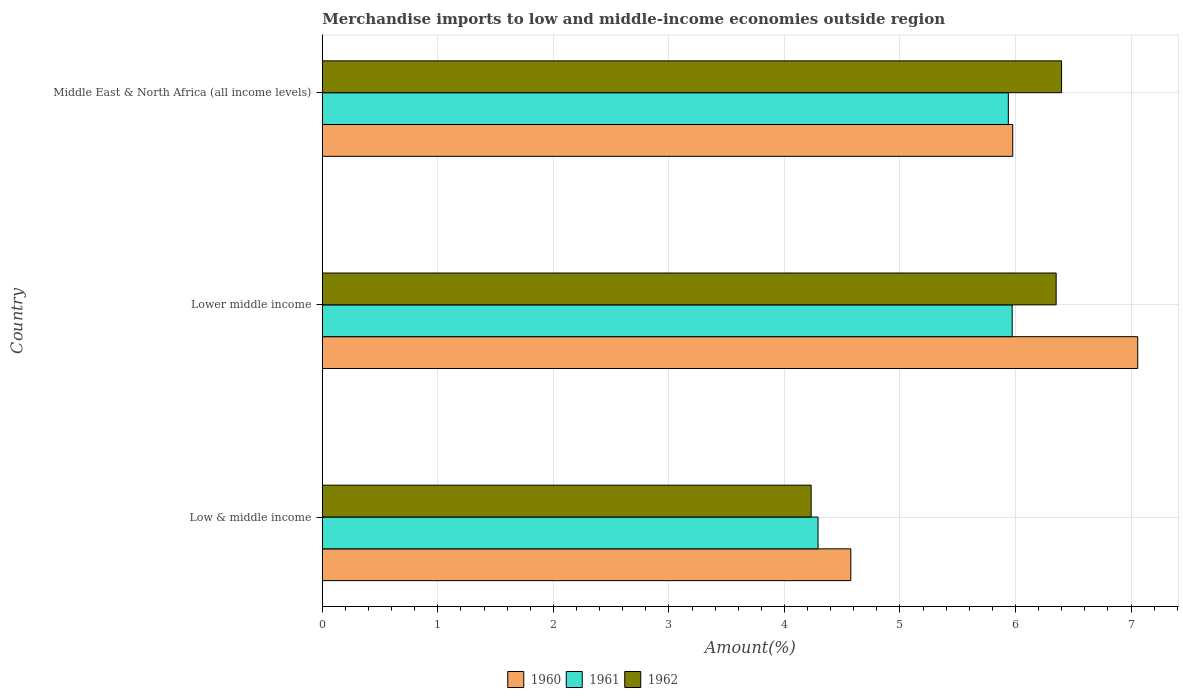How many different coloured bars are there?
Your response must be concise. 3. Are the number of bars per tick equal to the number of legend labels?
Your response must be concise. Yes. How many bars are there on the 3rd tick from the top?
Your response must be concise. 3. How many bars are there on the 1st tick from the bottom?
Provide a short and direct response. 3. What is the label of the 2nd group of bars from the top?
Provide a succinct answer. Lower middle income. What is the percentage of amount earned from merchandise imports in 1961 in Middle East & North Africa (all income levels)?
Provide a succinct answer. 5.94. Across all countries, what is the maximum percentage of amount earned from merchandise imports in 1960?
Give a very brief answer. 7.06. Across all countries, what is the minimum percentage of amount earned from merchandise imports in 1960?
Provide a short and direct response. 4.57. In which country was the percentage of amount earned from merchandise imports in 1961 maximum?
Keep it short and to the point. Lower middle income. In which country was the percentage of amount earned from merchandise imports in 1961 minimum?
Give a very brief answer. Low & middle income. What is the total percentage of amount earned from merchandise imports in 1960 in the graph?
Make the answer very short. 17.61. What is the difference between the percentage of amount earned from merchandise imports in 1960 in Low & middle income and that in Lower middle income?
Your answer should be compact. -2.48. What is the difference between the percentage of amount earned from merchandise imports in 1960 in Lower middle income and the percentage of amount earned from merchandise imports in 1962 in Middle East & North Africa (all income levels)?
Give a very brief answer. 0.66. What is the average percentage of amount earned from merchandise imports in 1960 per country?
Offer a terse response. 5.87. What is the difference between the percentage of amount earned from merchandise imports in 1961 and percentage of amount earned from merchandise imports in 1962 in Middle East & North Africa (all income levels)?
Keep it short and to the point. -0.46. In how many countries, is the percentage of amount earned from merchandise imports in 1962 greater than 4 %?
Offer a terse response. 3. What is the ratio of the percentage of amount earned from merchandise imports in 1960 in Lower middle income to that in Middle East & North Africa (all income levels)?
Offer a very short reply. 1.18. Is the difference between the percentage of amount earned from merchandise imports in 1961 in Low & middle income and Middle East & North Africa (all income levels) greater than the difference between the percentage of amount earned from merchandise imports in 1962 in Low & middle income and Middle East & North Africa (all income levels)?
Provide a succinct answer. Yes. What is the difference between the highest and the second highest percentage of amount earned from merchandise imports in 1962?
Ensure brevity in your answer.  0.05. What is the difference between the highest and the lowest percentage of amount earned from merchandise imports in 1962?
Give a very brief answer. 2.17. In how many countries, is the percentage of amount earned from merchandise imports in 1961 greater than the average percentage of amount earned from merchandise imports in 1961 taken over all countries?
Offer a very short reply. 2. What does the 2nd bar from the top in Middle East & North Africa (all income levels) represents?
Keep it short and to the point. 1961. What does the 2nd bar from the bottom in Middle East & North Africa (all income levels) represents?
Provide a short and direct response. 1961. Are all the bars in the graph horizontal?
Your response must be concise. Yes. How many countries are there in the graph?
Offer a terse response. 3. What is the difference between two consecutive major ticks on the X-axis?
Your answer should be compact. 1. Are the values on the major ticks of X-axis written in scientific E-notation?
Your response must be concise. No. Does the graph contain any zero values?
Your answer should be very brief. No. Does the graph contain grids?
Offer a very short reply. Yes. How many legend labels are there?
Keep it short and to the point. 3. How are the legend labels stacked?
Keep it short and to the point. Horizontal. What is the title of the graph?
Provide a short and direct response. Merchandise imports to low and middle-income economies outside region. What is the label or title of the X-axis?
Your response must be concise. Amount(%). What is the Amount(%) in 1960 in Low & middle income?
Give a very brief answer. 4.57. What is the Amount(%) in 1961 in Low & middle income?
Offer a very short reply. 4.29. What is the Amount(%) in 1962 in Low & middle income?
Provide a succinct answer. 4.23. What is the Amount(%) of 1960 in Lower middle income?
Offer a very short reply. 7.06. What is the Amount(%) of 1961 in Lower middle income?
Give a very brief answer. 5.97. What is the Amount(%) in 1962 in Lower middle income?
Your response must be concise. 6.35. What is the Amount(%) of 1960 in Middle East & North Africa (all income levels)?
Your answer should be compact. 5.98. What is the Amount(%) in 1961 in Middle East & North Africa (all income levels)?
Provide a succinct answer. 5.94. What is the Amount(%) in 1962 in Middle East & North Africa (all income levels)?
Give a very brief answer. 6.4. Across all countries, what is the maximum Amount(%) in 1960?
Ensure brevity in your answer.  7.06. Across all countries, what is the maximum Amount(%) of 1961?
Ensure brevity in your answer.  5.97. Across all countries, what is the maximum Amount(%) of 1962?
Your answer should be very brief. 6.4. Across all countries, what is the minimum Amount(%) of 1960?
Offer a terse response. 4.57. Across all countries, what is the minimum Amount(%) of 1961?
Provide a short and direct response. 4.29. Across all countries, what is the minimum Amount(%) of 1962?
Give a very brief answer. 4.23. What is the total Amount(%) in 1960 in the graph?
Your answer should be very brief. 17.61. What is the total Amount(%) in 1961 in the graph?
Your answer should be compact. 16.2. What is the total Amount(%) in 1962 in the graph?
Keep it short and to the point. 16.98. What is the difference between the Amount(%) of 1960 in Low & middle income and that in Lower middle income?
Keep it short and to the point. -2.48. What is the difference between the Amount(%) in 1961 in Low & middle income and that in Lower middle income?
Keep it short and to the point. -1.68. What is the difference between the Amount(%) of 1962 in Low & middle income and that in Lower middle income?
Provide a short and direct response. -2.12. What is the difference between the Amount(%) of 1960 in Low & middle income and that in Middle East & North Africa (all income levels)?
Provide a short and direct response. -1.4. What is the difference between the Amount(%) in 1961 in Low & middle income and that in Middle East & North Africa (all income levels)?
Your answer should be very brief. -1.65. What is the difference between the Amount(%) in 1962 in Low & middle income and that in Middle East & North Africa (all income levels)?
Give a very brief answer. -2.17. What is the difference between the Amount(%) of 1960 in Lower middle income and that in Middle East & North Africa (all income levels)?
Make the answer very short. 1.08. What is the difference between the Amount(%) in 1961 in Lower middle income and that in Middle East & North Africa (all income levels)?
Ensure brevity in your answer.  0.03. What is the difference between the Amount(%) of 1962 in Lower middle income and that in Middle East & North Africa (all income levels)?
Make the answer very short. -0.05. What is the difference between the Amount(%) of 1960 in Low & middle income and the Amount(%) of 1961 in Lower middle income?
Provide a short and direct response. -1.4. What is the difference between the Amount(%) in 1960 in Low & middle income and the Amount(%) in 1962 in Lower middle income?
Give a very brief answer. -1.78. What is the difference between the Amount(%) in 1961 in Low & middle income and the Amount(%) in 1962 in Lower middle income?
Keep it short and to the point. -2.06. What is the difference between the Amount(%) of 1960 in Low & middle income and the Amount(%) of 1961 in Middle East & North Africa (all income levels)?
Your answer should be very brief. -1.36. What is the difference between the Amount(%) of 1960 in Low & middle income and the Amount(%) of 1962 in Middle East & North Africa (all income levels)?
Ensure brevity in your answer.  -1.82. What is the difference between the Amount(%) of 1961 in Low & middle income and the Amount(%) of 1962 in Middle East & North Africa (all income levels)?
Your response must be concise. -2.11. What is the difference between the Amount(%) of 1960 in Lower middle income and the Amount(%) of 1961 in Middle East & North Africa (all income levels)?
Make the answer very short. 1.12. What is the difference between the Amount(%) in 1960 in Lower middle income and the Amount(%) in 1962 in Middle East & North Africa (all income levels)?
Provide a short and direct response. 0.66. What is the difference between the Amount(%) of 1961 in Lower middle income and the Amount(%) of 1962 in Middle East & North Africa (all income levels)?
Offer a terse response. -0.43. What is the average Amount(%) in 1960 per country?
Provide a short and direct response. 5.87. What is the average Amount(%) of 1961 per country?
Ensure brevity in your answer.  5.4. What is the average Amount(%) in 1962 per country?
Ensure brevity in your answer.  5.66. What is the difference between the Amount(%) in 1960 and Amount(%) in 1961 in Low & middle income?
Provide a short and direct response. 0.28. What is the difference between the Amount(%) of 1960 and Amount(%) of 1962 in Low & middle income?
Offer a terse response. 0.34. What is the difference between the Amount(%) in 1961 and Amount(%) in 1962 in Low & middle income?
Your response must be concise. 0.06. What is the difference between the Amount(%) in 1960 and Amount(%) in 1961 in Lower middle income?
Provide a succinct answer. 1.09. What is the difference between the Amount(%) of 1960 and Amount(%) of 1962 in Lower middle income?
Your answer should be compact. 0.71. What is the difference between the Amount(%) in 1961 and Amount(%) in 1962 in Lower middle income?
Keep it short and to the point. -0.38. What is the difference between the Amount(%) in 1960 and Amount(%) in 1961 in Middle East & North Africa (all income levels)?
Ensure brevity in your answer.  0.04. What is the difference between the Amount(%) in 1960 and Amount(%) in 1962 in Middle East & North Africa (all income levels)?
Ensure brevity in your answer.  -0.42. What is the difference between the Amount(%) in 1961 and Amount(%) in 1962 in Middle East & North Africa (all income levels)?
Keep it short and to the point. -0.46. What is the ratio of the Amount(%) of 1960 in Low & middle income to that in Lower middle income?
Give a very brief answer. 0.65. What is the ratio of the Amount(%) in 1961 in Low & middle income to that in Lower middle income?
Your response must be concise. 0.72. What is the ratio of the Amount(%) of 1962 in Low & middle income to that in Lower middle income?
Provide a succinct answer. 0.67. What is the ratio of the Amount(%) in 1960 in Low & middle income to that in Middle East & North Africa (all income levels)?
Make the answer very short. 0.77. What is the ratio of the Amount(%) of 1961 in Low & middle income to that in Middle East & North Africa (all income levels)?
Offer a terse response. 0.72. What is the ratio of the Amount(%) in 1962 in Low & middle income to that in Middle East & North Africa (all income levels)?
Provide a succinct answer. 0.66. What is the ratio of the Amount(%) in 1960 in Lower middle income to that in Middle East & North Africa (all income levels)?
Offer a very short reply. 1.18. What is the ratio of the Amount(%) in 1961 in Lower middle income to that in Middle East & North Africa (all income levels)?
Offer a very short reply. 1.01. What is the ratio of the Amount(%) in 1962 in Lower middle income to that in Middle East & North Africa (all income levels)?
Give a very brief answer. 0.99. What is the difference between the highest and the second highest Amount(%) of 1960?
Your answer should be very brief. 1.08. What is the difference between the highest and the second highest Amount(%) in 1961?
Your response must be concise. 0.03. What is the difference between the highest and the second highest Amount(%) in 1962?
Your answer should be very brief. 0.05. What is the difference between the highest and the lowest Amount(%) of 1960?
Offer a very short reply. 2.48. What is the difference between the highest and the lowest Amount(%) in 1961?
Your response must be concise. 1.68. What is the difference between the highest and the lowest Amount(%) in 1962?
Make the answer very short. 2.17. 